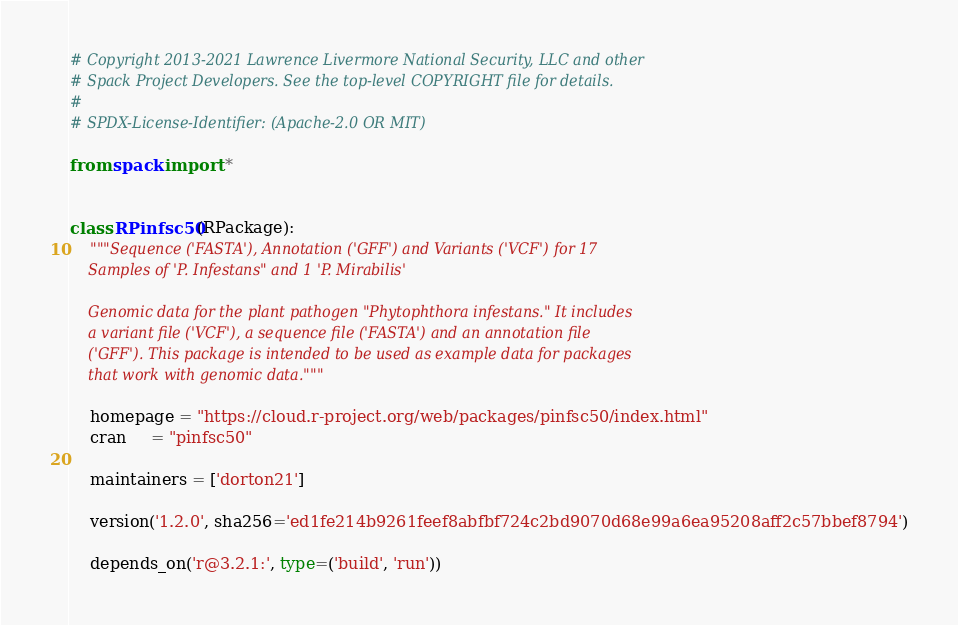Convert code to text. <code><loc_0><loc_0><loc_500><loc_500><_Python_># Copyright 2013-2021 Lawrence Livermore National Security, LLC and other
# Spack Project Developers. See the top-level COPYRIGHT file for details.
#
# SPDX-License-Identifier: (Apache-2.0 OR MIT)

from spack import *


class RPinfsc50(RPackage):
    """Sequence ('FASTA'), Annotation ('GFF') and Variants ('VCF') for 17
    Samples of 'P. Infestans" and 1 'P. Mirabilis'

    Genomic data for the plant pathogen "Phytophthora infestans." It includes
    a variant file ('VCF'), a sequence file ('FASTA') and an annotation file
    ('GFF'). This package is intended to be used as example data for packages
    that work with genomic data."""

    homepage = "https://cloud.r-project.org/web/packages/pinfsc50/index.html"
    cran     = "pinfsc50"

    maintainers = ['dorton21']

    version('1.2.0', sha256='ed1fe214b9261feef8abfbf724c2bd9070d68e99a6ea95208aff2c57bbef8794')

    depends_on('r@3.2.1:', type=('build', 'run'))
</code> 